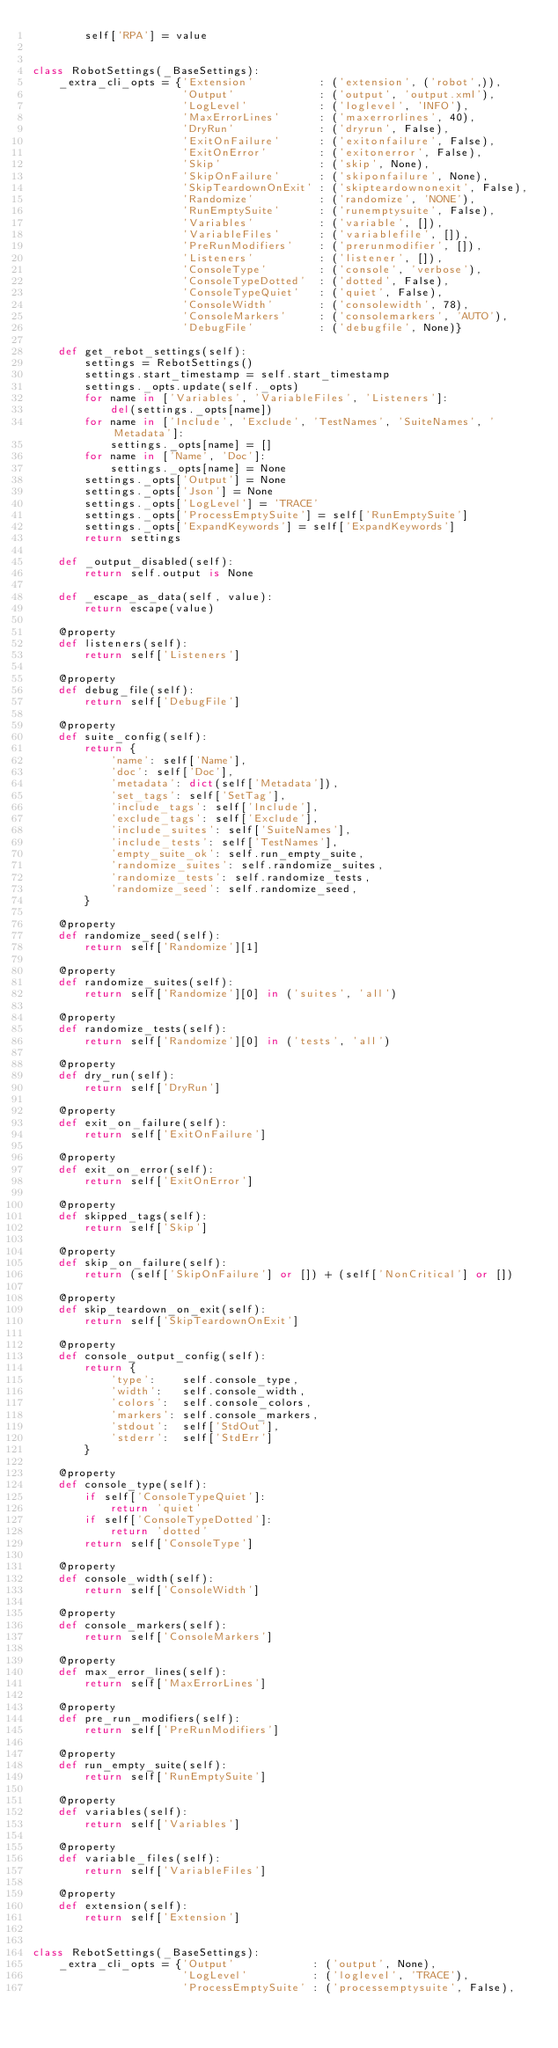Convert code to text. <code><loc_0><loc_0><loc_500><loc_500><_Python_>        self['RPA'] = value


class RobotSettings(_BaseSettings):
    _extra_cli_opts = {'Extension'          : ('extension', ('robot',)),
                       'Output'             : ('output', 'output.xml'),
                       'LogLevel'           : ('loglevel', 'INFO'),
                       'MaxErrorLines'      : ('maxerrorlines', 40),
                       'DryRun'             : ('dryrun', False),
                       'ExitOnFailure'      : ('exitonfailure', False),
                       'ExitOnError'        : ('exitonerror', False),
                       'Skip'               : ('skip', None),
                       'SkipOnFailure'      : ('skiponfailure', None),
                       'SkipTeardownOnExit' : ('skipteardownonexit', False),
                       'Randomize'          : ('randomize', 'NONE'),
                       'RunEmptySuite'      : ('runemptysuite', False),
                       'Variables'          : ('variable', []),
                       'VariableFiles'      : ('variablefile', []),
                       'PreRunModifiers'    : ('prerunmodifier', []),
                       'Listeners'          : ('listener', []),
                       'ConsoleType'        : ('console', 'verbose'),
                       'ConsoleTypeDotted'  : ('dotted', False),
                       'ConsoleTypeQuiet'   : ('quiet', False),
                       'ConsoleWidth'       : ('consolewidth', 78),
                       'ConsoleMarkers'     : ('consolemarkers', 'AUTO'),
                       'DebugFile'          : ('debugfile', None)}

    def get_rebot_settings(self):
        settings = RebotSettings()
        settings.start_timestamp = self.start_timestamp
        settings._opts.update(self._opts)
        for name in ['Variables', 'VariableFiles', 'Listeners']:
            del(settings._opts[name])
        for name in ['Include', 'Exclude', 'TestNames', 'SuiteNames', 'Metadata']:
            settings._opts[name] = []
        for name in ['Name', 'Doc']:
            settings._opts[name] = None
        settings._opts['Output'] = None
        settings._opts['Json'] = None
        settings._opts['LogLevel'] = 'TRACE'
        settings._opts['ProcessEmptySuite'] = self['RunEmptySuite']
        settings._opts['ExpandKeywords'] = self['ExpandKeywords']
        return settings

    def _output_disabled(self):
        return self.output is None

    def _escape_as_data(self, value):
        return escape(value)

    @property
    def listeners(self):
        return self['Listeners']

    @property
    def debug_file(self):
        return self['DebugFile']

    @property
    def suite_config(self):
        return {
            'name': self['Name'],
            'doc': self['Doc'],
            'metadata': dict(self['Metadata']),
            'set_tags': self['SetTag'],
            'include_tags': self['Include'],
            'exclude_tags': self['Exclude'],
            'include_suites': self['SuiteNames'],
            'include_tests': self['TestNames'],
            'empty_suite_ok': self.run_empty_suite,
            'randomize_suites': self.randomize_suites,
            'randomize_tests': self.randomize_tests,
            'randomize_seed': self.randomize_seed,
        }

    @property
    def randomize_seed(self):
        return self['Randomize'][1]

    @property
    def randomize_suites(self):
        return self['Randomize'][0] in ('suites', 'all')

    @property
    def randomize_tests(self):
        return self['Randomize'][0] in ('tests', 'all')

    @property
    def dry_run(self):
        return self['DryRun']

    @property
    def exit_on_failure(self):
        return self['ExitOnFailure']

    @property
    def exit_on_error(self):
        return self['ExitOnError']

    @property
    def skipped_tags(self):
        return self['Skip']

    @property
    def skip_on_failure(self):
        return (self['SkipOnFailure'] or []) + (self['NonCritical'] or [])

    @property
    def skip_teardown_on_exit(self):
        return self['SkipTeardownOnExit']

    @property
    def console_output_config(self):
        return {
            'type':    self.console_type,
            'width':   self.console_width,
            'colors':  self.console_colors,
            'markers': self.console_markers,
            'stdout':  self['StdOut'],
            'stderr':  self['StdErr']
        }

    @property
    def console_type(self):
        if self['ConsoleTypeQuiet']:
            return 'quiet'
        if self['ConsoleTypeDotted']:
            return 'dotted'
        return self['ConsoleType']

    @property
    def console_width(self):
        return self['ConsoleWidth']

    @property
    def console_markers(self):
        return self['ConsoleMarkers']

    @property
    def max_error_lines(self):
        return self['MaxErrorLines']

    @property
    def pre_run_modifiers(self):
        return self['PreRunModifiers']

    @property
    def run_empty_suite(self):
        return self['RunEmptySuite']

    @property
    def variables(self):
        return self['Variables']

    @property
    def variable_files(self):
        return self['VariableFiles']

    @property
    def extension(self):
        return self['Extension']


class RebotSettings(_BaseSettings):
    _extra_cli_opts = {'Output'            : ('output', None),
                       'LogLevel'          : ('loglevel', 'TRACE'),
                       'ProcessEmptySuite' : ('processemptysuite', False),</code> 